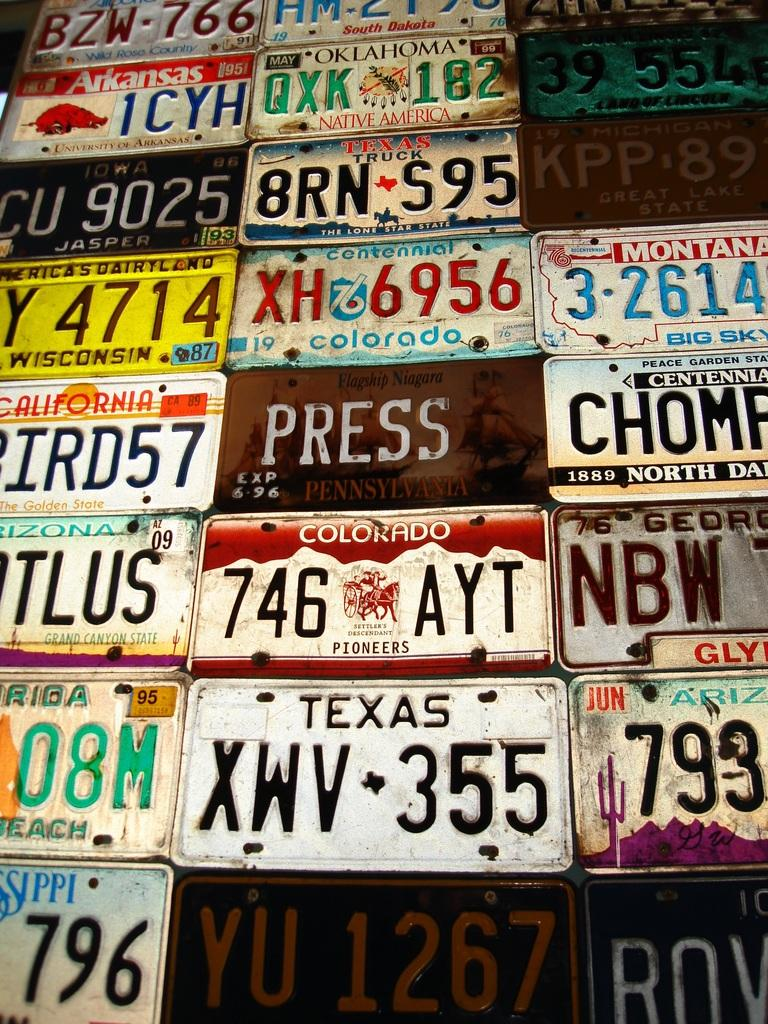What objects are present in the image that have text and numbers? There are name plates in the image that have text and numbers on them. Can you describe the text on the name plates? Unfortunately, the specific text on the name plates cannot be determined from the image alone. What purpose might the numbers on the name plates serve? The numbers on the name plates could serve as identification or organization markers. Can you see a balloon floating above the name plates in the image? There is no balloon present in the image; it only features name plates with text and numbers. 